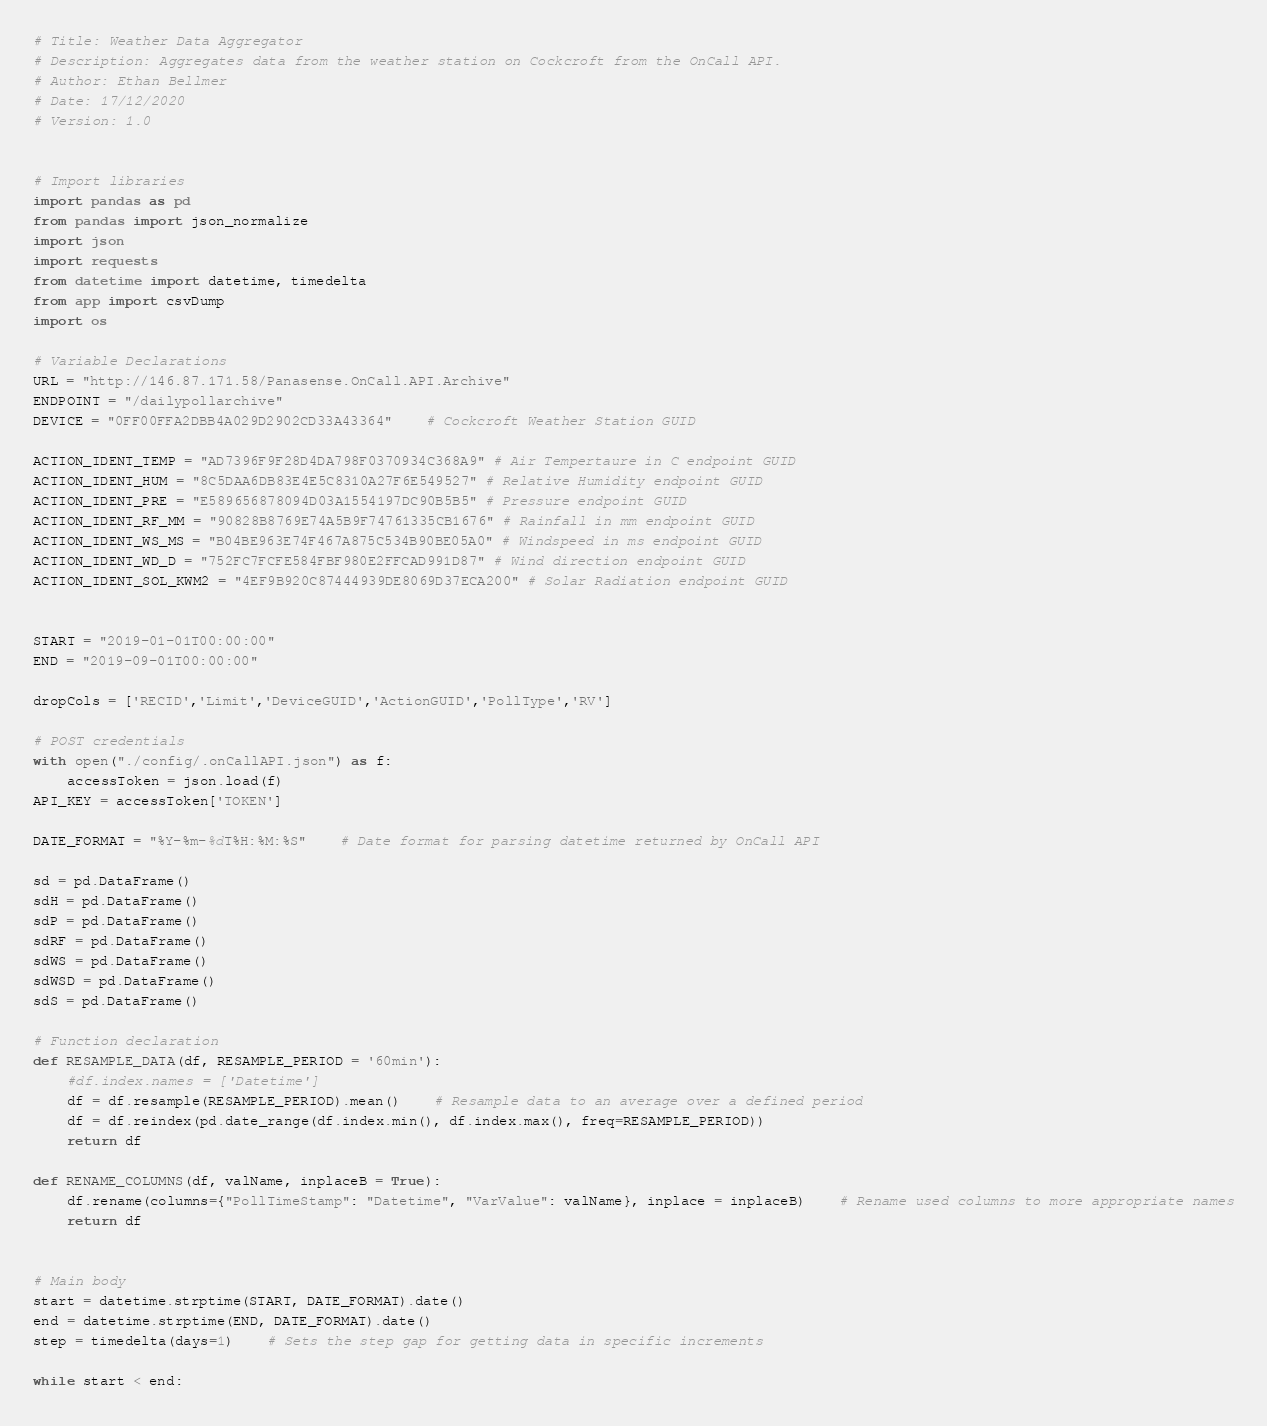<code> <loc_0><loc_0><loc_500><loc_500><_Python_># Title: Weather Data Aggregator
# Description: Aggregates data from the weather station on Cockcroft from the OnCall API.
# Author: Ethan Bellmer
# Date: 17/12/2020
# Version: 1.0


# Import libraries
import pandas as pd
from pandas import json_normalize
import json
import requests
from datetime import datetime, timedelta
from app import csvDump
import os

# Variable Declarations
URL = "http://146.87.171.58/Panasense.OnCall.API.Archive"
ENDPOINT = "/dailypollarchive"
DEVICE = "0FF00FFA2DBB4A029D2902CD33A43364"	# Cockcroft Weather Station GUID

ACTION_IDENT_TEMP = "AD7396F9F28D4DA798F0370934C368A9" # Air Tempertaure in C endpoint GUID
ACTION_IDENT_HUM = "8C5DAA6DB83E4E5C8310A27F6E549527" # Relative Humidity endpoint GUID
ACTION_IDENT_PRE = "E589656878094D03A1554197DC90B5B5" # Pressure endpoint GUID
ACTION_IDENT_RF_MM = "90828B8769E74A5B9F74761335CB1676" # Rainfall in mm endpoint GUID
ACTION_IDENT_WS_MS = "B04BE963E74F467A875C534B90BE05A0" # Windspeed in ms endpoint GUID
ACTION_IDENT_WD_D = "752FC7FCFE584FBF980E2FFCAD991D87" # Wind direction endpoint GUID
ACTION_IDENT_SOL_KWM2 = "4EF9B920C87444939DE8069D37ECA200" # Solar Radiation endpoint GUID


START = "2019-01-01T00:00:00"
END = "2019-09-01T00:00:00"

dropCols = ['RECID','Limit','DeviceGUID','ActionGUID','PollType','RV']

# POST credentials
with open("./config/.onCallAPI.json") as f:
	accessToken = json.load(f)
API_KEY = accessToken['TOKEN']

DATE_FORMAT = "%Y-%m-%dT%H:%M:%S"	# Date format for parsing datetime returned by OnCall API

sd = pd.DataFrame()
sdH = pd.DataFrame()
sdP = pd.DataFrame()
sdRF = pd.DataFrame()
sdWS = pd.DataFrame()
sdWSD = pd.DataFrame()
sdS = pd.DataFrame()

# Function declaration
def RESAMPLE_DATA(df, RESAMPLE_PERIOD = '60min'):
	#df.index.names = ['Datetime']
	df = df.resample(RESAMPLE_PERIOD).mean()	# Resample data to an average over a defined period
	df = df.reindex(pd.date_range(df.index.min(), df.index.max(), freq=RESAMPLE_PERIOD))
	return df

def RENAME_COLUMNS(df, valName, inplaceB = True):
	df.rename(columns={"PollTimeStamp": "Datetime", "VarValue": valName}, inplace = inplaceB)	# Rename used columns to more appropriate names
	return df


# Main body
start = datetime.strptime(START, DATE_FORMAT).date()
end = datetime.strptime(END, DATE_FORMAT).date()
step = timedelta(days=1)	# Sets the step gap for getting data in specific increments

while start < end:</code> 